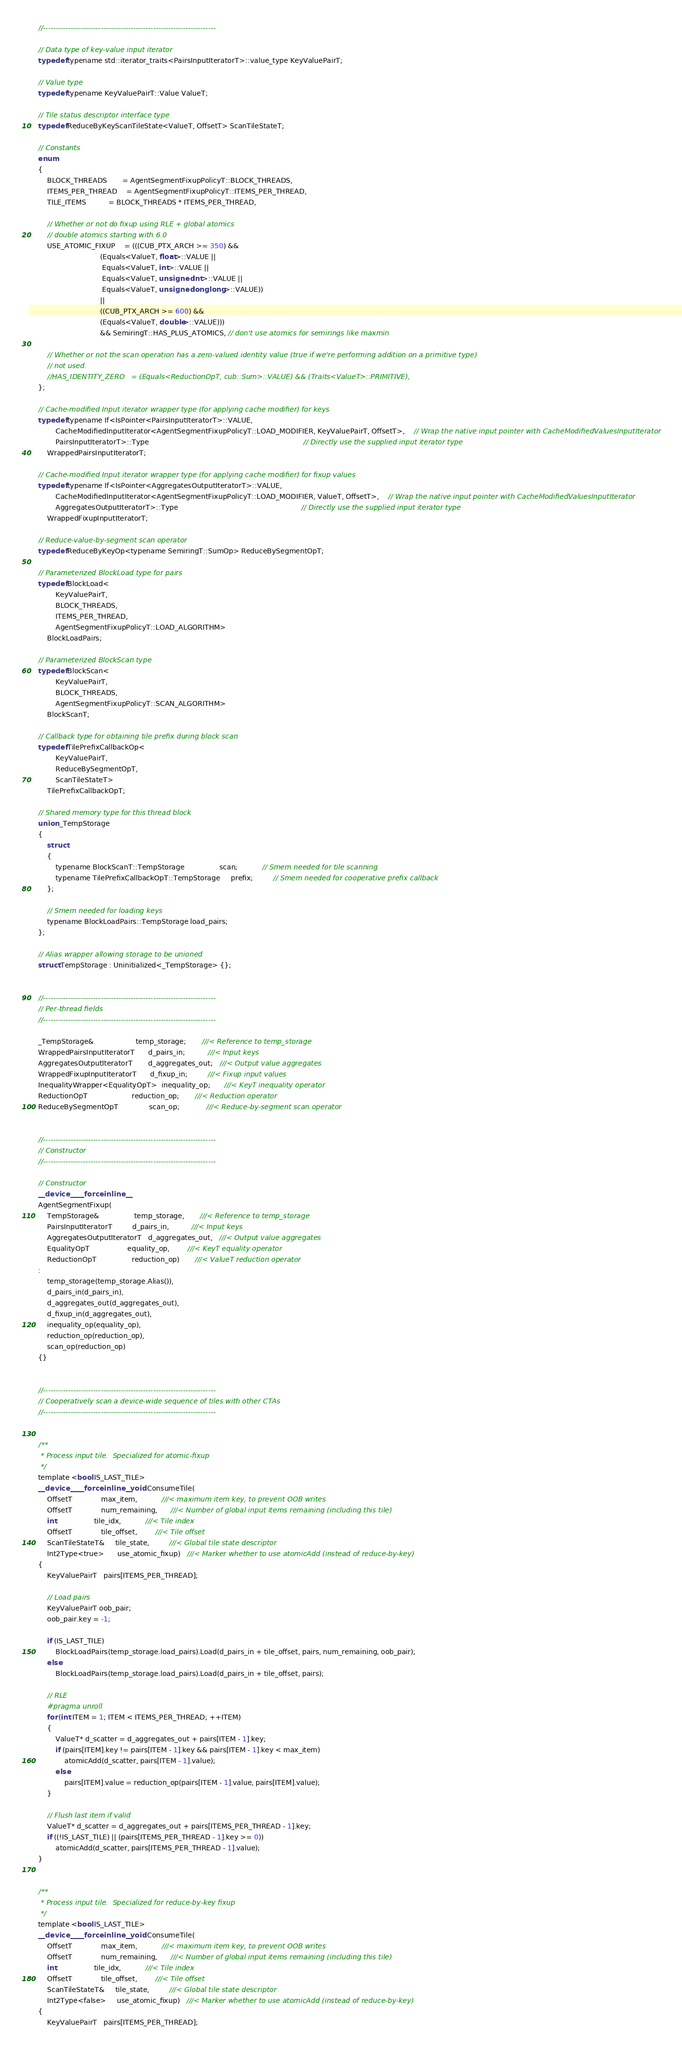Convert code to text. <code><loc_0><loc_0><loc_500><loc_500><_Cuda_>    //---------------------------------------------------------------------

    // Data type of key-value input iterator
    typedef typename std::iterator_traits<PairsInputIteratorT>::value_type KeyValuePairT;

    // Value type
    typedef typename KeyValuePairT::Value ValueT;

    // Tile status descriptor interface type
    typedef ReduceByKeyScanTileState<ValueT, OffsetT> ScanTileStateT;

    // Constants
    enum
    {
        BLOCK_THREADS       = AgentSegmentFixupPolicyT::BLOCK_THREADS,
        ITEMS_PER_THREAD    = AgentSegmentFixupPolicyT::ITEMS_PER_THREAD,
        TILE_ITEMS          = BLOCK_THREADS * ITEMS_PER_THREAD,

        // Whether or not do fixup using RLE + global atomics
        // double atomics starting with 6.0
        USE_ATOMIC_FIXUP    = (((CUB_PTX_ARCH >= 350) && 
                                (Equals<ValueT, float>::VALUE || 
                                 Equals<ValueT, int>::VALUE ||
                                 Equals<ValueT, unsigned int>::VALUE ||
                                 Equals<ValueT, unsigned long long>::VALUE)) 
                                ||
                                ((CUB_PTX_ARCH >= 600) && 
                                (Equals<ValueT, double>::VALUE)))
                                && SemiringT::HAS_PLUS_ATOMICS, // don't use atomics for semirings like maxmin

        // Whether or not the scan operation has a zero-valued identity value (true if we're performing addition on a primitive type)
        // not used. 
        //HAS_IDENTITY_ZERO   = (Equals<ReductionOpT, cub::Sum>::VALUE) && (Traits<ValueT>::PRIMITIVE),
    };

    // Cache-modified Input iterator wrapper type (for applying cache modifier) for keys
    typedef typename If<IsPointer<PairsInputIteratorT>::VALUE,
            CacheModifiedInputIterator<AgentSegmentFixupPolicyT::LOAD_MODIFIER, KeyValuePairT, OffsetT>,    // Wrap the native input pointer with CacheModifiedValuesInputIterator
            PairsInputIteratorT>::Type                                                                      // Directly use the supplied input iterator type
        WrappedPairsInputIteratorT;

    // Cache-modified Input iterator wrapper type (for applying cache modifier) for fixup values
    typedef typename If<IsPointer<AggregatesOutputIteratorT>::VALUE,
            CacheModifiedInputIterator<AgentSegmentFixupPolicyT::LOAD_MODIFIER, ValueT, OffsetT>,    // Wrap the native input pointer with CacheModifiedValuesInputIterator
            AggregatesOutputIteratorT>::Type                                                        // Directly use the supplied input iterator type
        WrappedFixupInputIteratorT;

    // Reduce-value-by-segment scan operator
    typedef ReduceByKeyOp<typename SemiringT::SumOp> ReduceBySegmentOpT;

    // Parameterized BlockLoad type for pairs
    typedef BlockLoad<
            KeyValuePairT,
            BLOCK_THREADS,
            ITEMS_PER_THREAD,
            AgentSegmentFixupPolicyT::LOAD_ALGORITHM>
        BlockLoadPairs;

    // Parameterized BlockScan type
    typedef BlockScan<
            KeyValuePairT,
            BLOCK_THREADS,
            AgentSegmentFixupPolicyT::SCAN_ALGORITHM>
        BlockScanT;

    // Callback type for obtaining tile prefix during block scan
    typedef TilePrefixCallbackOp<
            KeyValuePairT,
            ReduceBySegmentOpT,
            ScanTileStateT>
        TilePrefixCallbackOpT;

    // Shared memory type for this thread block
    union _TempStorage
    {
        struct
        {
            typename BlockScanT::TempStorage                scan;           // Smem needed for tile scanning
            typename TilePrefixCallbackOpT::TempStorage     prefix;         // Smem needed for cooperative prefix callback
        };

        // Smem needed for loading keys
        typename BlockLoadPairs::TempStorage load_pairs;
    };

    // Alias wrapper allowing storage to be unioned
    struct TempStorage : Uninitialized<_TempStorage> {};


    //---------------------------------------------------------------------
    // Per-thread fields
    //---------------------------------------------------------------------

    _TempStorage&                   temp_storage;       ///< Reference to temp_storage
    WrappedPairsInputIteratorT      d_pairs_in;          ///< Input keys
    AggregatesOutputIteratorT       d_aggregates_out;   ///< Output value aggregates
    WrappedFixupInputIteratorT      d_fixup_in;         ///< Fixup input values
    InequalityWrapper<EqualityOpT>  inequality_op;      ///< KeyT inequality operator
    ReductionOpT                    reduction_op;       ///< Reduction operator
    ReduceBySegmentOpT              scan_op;            ///< Reduce-by-segment scan operator


    //---------------------------------------------------------------------
    // Constructor
    //---------------------------------------------------------------------

    // Constructor
    __device__ __forceinline__
    AgentSegmentFixup(
        TempStorage&                temp_storage,       ///< Reference to temp_storage
        PairsInputIteratorT         d_pairs_in,          ///< Input keys
        AggregatesOutputIteratorT   d_aggregates_out,   ///< Output value aggregates
        EqualityOpT                 equality_op,        ///< KeyT equality operator
        ReductionOpT                reduction_op)       ///< ValueT reduction operator
    :
        temp_storage(temp_storage.Alias()),
        d_pairs_in(d_pairs_in),
        d_aggregates_out(d_aggregates_out),
        d_fixup_in(d_aggregates_out),
        inequality_op(equality_op),
        reduction_op(reduction_op),
        scan_op(reduction_op)
    {}


    //---------------------------------------------------------------------
    // Cooperatively scan a device-wide sequence of tiles with other CTAs
    //---------------------------------------------------------------------


    /**
     * Process input tile.  Specialized for atomic-fixup
     */
    template <bool IS_LAST_TILE>
    __device__ __forceinline__ void ConsumeTile(
        OffsetT             max_item,           ///< maximum item key, to prevent OOB writes
        OffsetT             num_remaining,      ///< Number of global input items remaining (including this tile)
        int                 tile_idx,           ///< Tile index
        OffsetT             tile_offset,        ///< Tile offset
        ScanTileStateT&     tile_state,         ///< Global tile state descriptor
        Int2Type<true>      use_atomic_fixup)   ///< Marker whether to use atomicAdd (instead of reduce-by-key)
    {
        KeyValuePairT   pairs[ITEMS_PER_THREAD];

        // Load pairs
        KeyValuePairT oob_pair;
        oob_pair.key = -1;

        if (IS_LAST_TILE)
            BlockLoadPairs(temp_storage.load_pairs).Load(d_pairs_in + tile_offset, pairs, num_remaining, oob_pair);
        else
            BlockLoadPairs(temp_storage.load_pairs).Load(d_pairs_in + tile_offset, pairs);

        // RLE 
        #pragma unroll
        for (int ITEM = 1; ITEM < ITEMS_PER_THREAD; ++ITEM)
        {
            ValueT* d_scatter = d_aggregates_out + pairs[ITEM - 1].key;
            if (pairs[ITEM].key != pairs[ITEM - 1].key && pairs[ITEM - 1].key < max_item)
                atomicAdd(d_scatter, pairs[ITEM - 1].value);
            else
                pairs[ITEM].value = reduction_op(pairs[ITEM - 1].value, pairs[ITEM].value);
        }

        // Flush last item if valid
        ValueT* d_scatter = d_aggregates_out + pairs[ITEMS_PER_THREAD - 1].key;
        if ((!IS_LAST_TILE) || (pairs[ITEMS_PER_THREAD - 1].key >= 0))
            atomicAdd(d_scatter, pairs[ITEMS_PER_THREAD - 1].value);
    }


    /**
     * Process input tile.  Specialized for reduce-by-key fixup
     */
    template <bool IS_LAST_TILE>
    __device__ __forceinline__ void ConsumeTile(
        OffsetT             max_item,           ///< maximum item key, to prevent OOB writes
        OffsetT             num_remaining,      ///< Number of global input items remaining (including this tile)
        int                 tile_idx,           ///< Tile index
        OffsetT             tile_offset,        ///< Tile offset
        ScanTileStateT&     tile_state,         ///< Global tile state descriptor
        Int2Type<false>     use_atomic_fixup)   ///< Marker whether to use atomicAdd (instead of reduce-by-key)
    {
        KeyValuePairT   pairs[ITEMS_PER_THREAD];</code> 